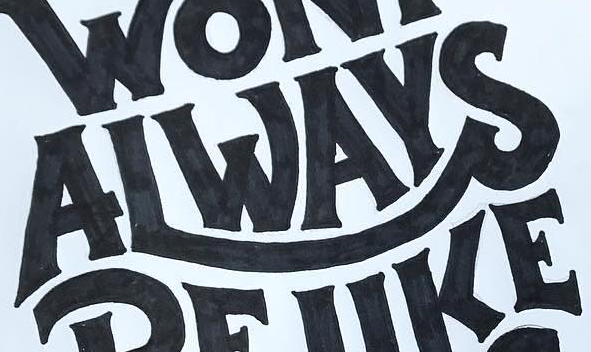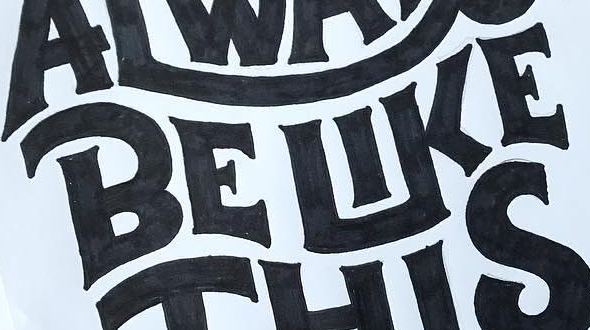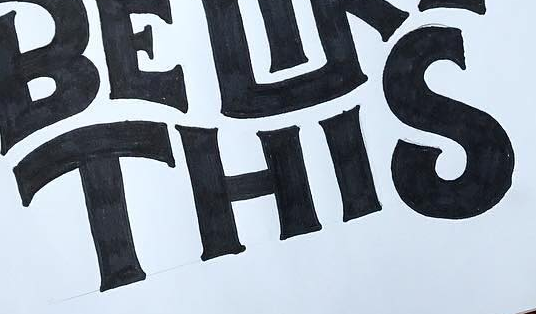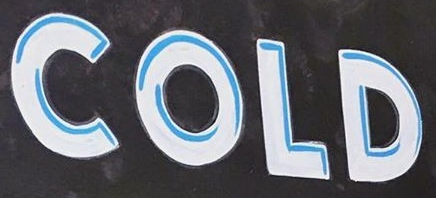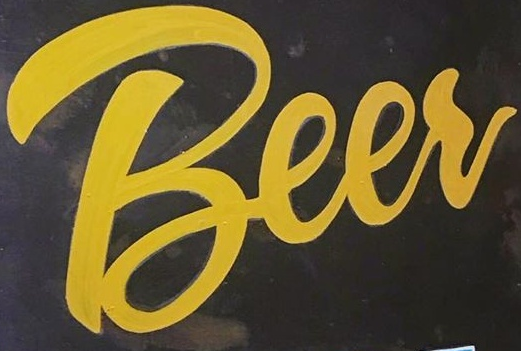Transcribe the words shown in these images in order, separated by a semicolon. ALWAYS; BELIKE; THIS; COLD; Beer 